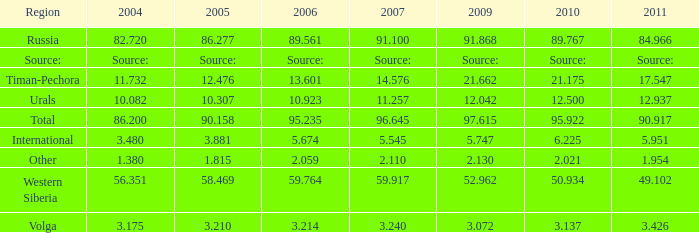What is the 2010 Lukoil oil prodroduction when in 2009 oil production 21.662 million tonnes? 21.175. 